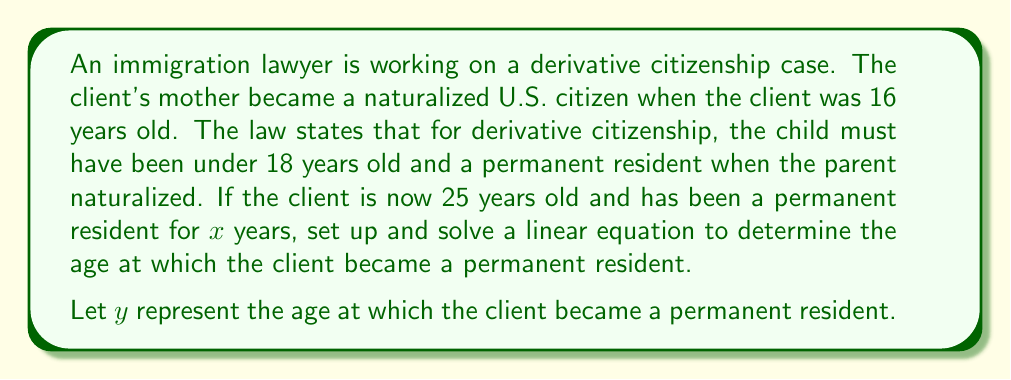Teach me how to tackle this problem. To solve this problem, we need to set up a linear equation using the given information:

1. The client is currently 25 years old.
2. The client has been a permanent resident for $x$ years.
3. The client was 16 when their mother became a naturalized U.S. citizen.

Let's set up the equation:

Current age = Age when became permanent resident + Years as permanent resident
$$25 = y + x$$

We know that the client must have become a permanent resident before their mother naturalized (at age 16) for derivative citizenship eligibility. So:

$$y \leq 16$$

Now, we can substitute $y$ in our original equation:
$$25 = 16 + x$$

Solving for $x$:
$$x = 25 - 16 = 9$$

This means the client has been a permanent resident for 9 years.

To find the age at which the client became a permanent resident:
$$y = 25 - 9 = 16$$

Therefore, the client became a permanent resident at age 16, just in time to potentially qualify for derivative citizenship when their mother naturalized.
Answer: The client became a permanent resident at age 16. 